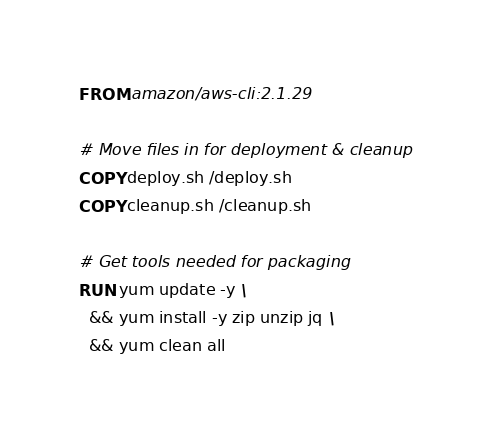<code> <loc_0><loc_0><loc_500><loc_500><_Dockerfile_>FROM amazon/aws-cli:2.1.29

# Move files in for deployment & cleanup
COPY deploy.sh /deploy.sh
COPY cleanup.sh /cleanup.sh

# Get tools needed for packaging
RUN yum update -y \
  && yum install -y zip unzip jq \
  && yum clean all
</code> 